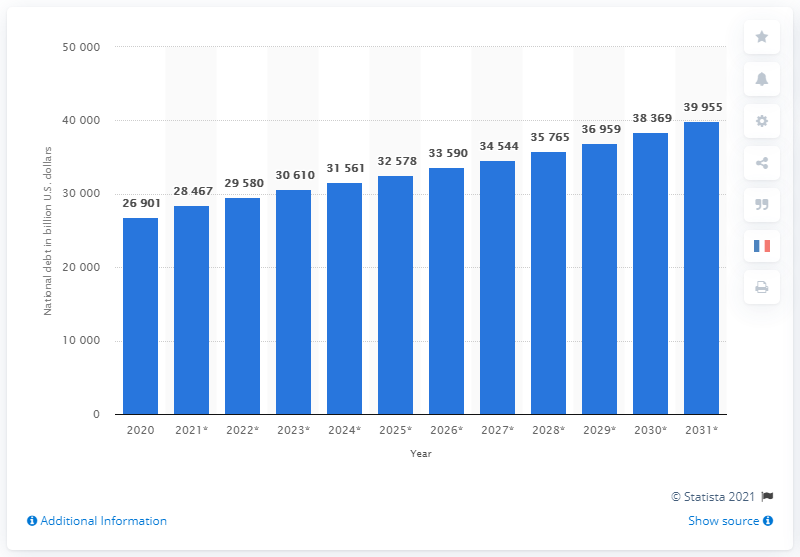Specify some key components in this picture. The gross federal debt of the United States is projected to be approximately 39,955 billion dollars by 2031, according to recent estimates. In 2020, the federal debt of the United States was approximately 269,010 dollars. 